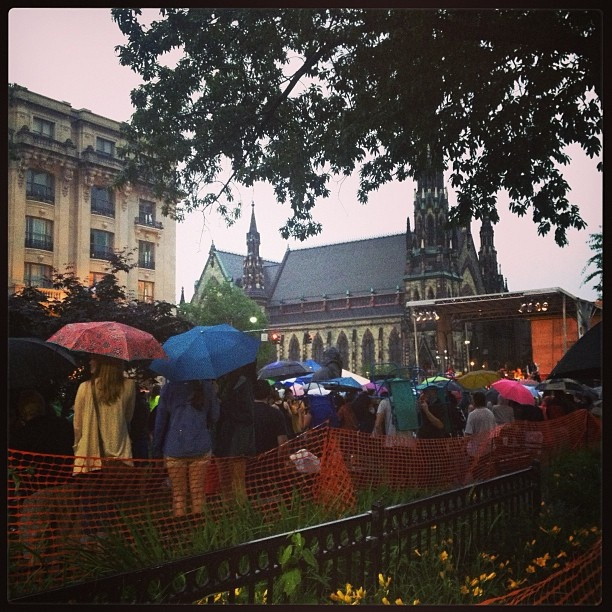Describe the objects in this image and their specific colors. I can see people in black and maroon tones, people in black, maroon, and olive tones, umbrella in black, blue, darkblue, and navy tones, people in black and maroon tones, and people in black, maroon, teal, and gray tones in this image. 